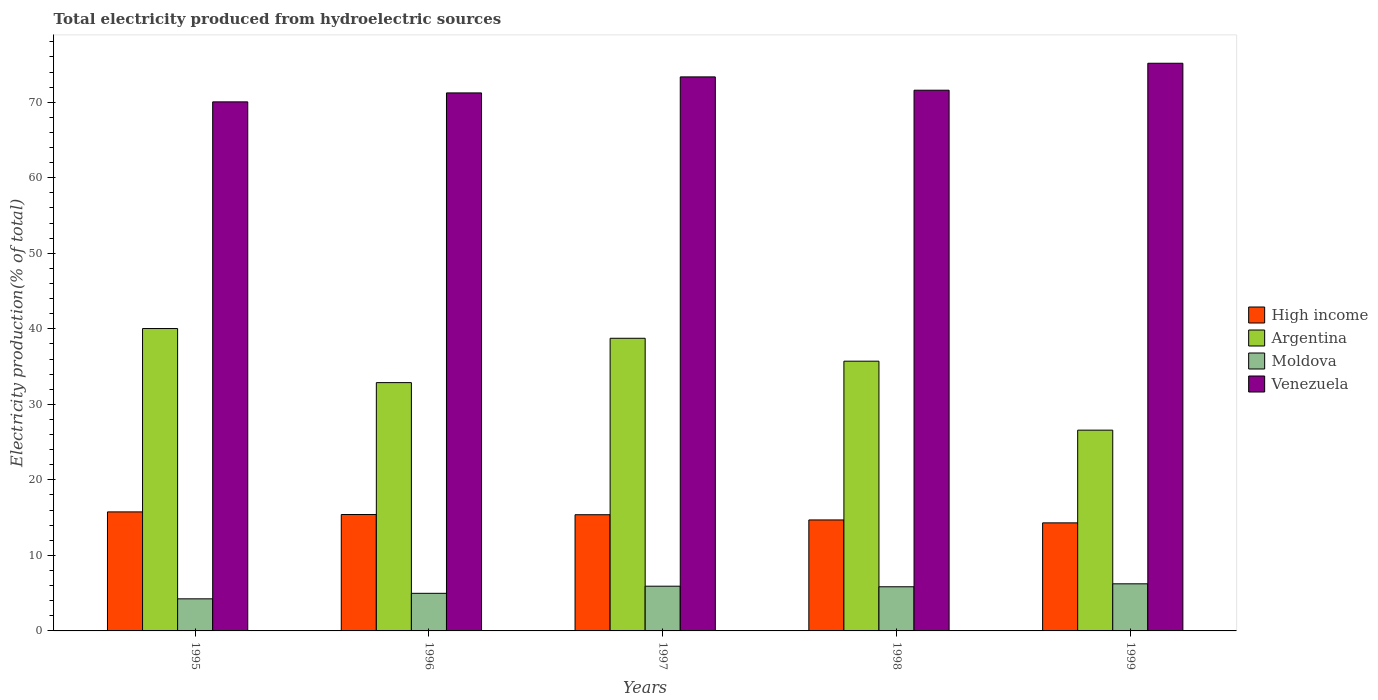Are the number of bars on each tick of the X-axis equal?
Ensure brevity in your answer.  Yes. What is the label of the 1st group of bars from the left?
Provide a succinct answer. 1995. What is the total electricity produced in High income in 1997?
Your answer should be compact. 15.39. Across all years, what is the maximum total electricity produced in Moldova?
Make the answer very short. 6.24. Across all years, what is the minimum total electricity produced in Moldova?
Your answer should be compact. 4.25. In which year was the total electricity produced in Venezuela maximum?
Provide a succinct answer. 1999. In which year was the total electricity produced in Venezuela minimum?
Your answer should be very brief. 1995. What is the total total electricity produced in High income in the graph?
Make the answer very short. 75.56. What is the difference between the total electricity produced in High income in 1995 and that in 1997?
Your answer should be very brief. 0.37. What is the difference between the total electricity produced in Argentina in 1996 and the total electricity produced in Venezuela in 1995?
Give a very brief answer. -37.17. What is the average total electricity produced in Argentina per year?
Provide a succinct answer. 34.79. In the year 1998, what is the difference between the total electricity produced in Moldova and total electricity produced in Venezuela?
Your answer should be very brief. -65.75. In how many years, is the total electricity produced in Venezuela greater than 10 %?
Offer a very short reply. 5. What is the ratio of the total electricity produced in Moldova in 1995 to that in 1997?
Keep it short and to the point. 0.72. Is the difference between the total electricity produced in Moldova in 1995 and 1998 greater than the difference between the total electricity produced in Venezuela in 1995 and 1998?
Ensure brevity in your answer.  No. What is the difference between the highest and the second highest total electricity produced in Venezuela?
Offer a terse response. 1.81. What is the difference between the highest and the lowest total electricity produced in Venezuela?
Give a very brief answer. 5.11. Is the sum of the total electricity produced in High income in 1997 and 1999 greater than the maximum total electricity produced in Moldova across all years?
Offer a terse response. Yes. What does the 1st bar from the right in 1995 represents?
Offer a terse response. Venezuela. How many bars are there?
Your response must be concise. 20. Does the graph contain grids?
Offer a very short reply. No. How many legend labels are there?
Your response must be concise. 4. How are the legend labels stacked?
Provide a succinct answer. Vertical. What is the title of the graph?
Ensure brevity in your answer.  Total electricity produced from hydroelectric sources. Does "Fragile and conflict affected situations" appear as one of the legend labels in the graph?
Your response must be concise. No. What is the label or title of the X-axis?
Offer a very short reply. Years. What is the label or title of the Y-axis?
Your answer should be very brief. Electricity production(% of total). What is the Electricity production(% of total) in High income in 1995?
Offer a terse response. 15.76. What is the Electricity production(% of total) in Argentina in 1995?
Ensure brevity in your answer.  40.04. What is the Electricity production(% of total) in Moldova in 1995?
Provide a short and direct response. 4.25. What is the Electricity production(% of total) in Venezuela in 1995?
Your answer should be compact. 70.05. What is the Electricity production(% of total) in High income in 1996?
Your response must be concise. 15.41. What is the Electricity production(% of total) in Argentina in 1996?
Keep it short and to the point. 32.88. What is the Electricity production(% of total) in Moldova in 1996?
Offer a very short reply. 4.98. What is the Electricity production(% of total) in Venezuela in 1996?
Provide a short and direct response. 71.24. What is the Electricity production(% of total) in High income in 1997?
Make the answer very short. 15.39. What is the Electricity production(% of total) of Argentina in 1997?
Your answer should be compact. 38.75. What is the Electricity production(% of total) of Moldova in 1997?
Offer a very short reply. 5.92. What is the Electricity production(% of total) in Venezuela in 1997?
Your answer should be compact. 73.36. What is the Electricity production(% of total) in High income in 1998?
Your response must be concise. 14.69. What is the Electricity production(% of total) in Argentina in 1998?
Provide a short and direct response. 35.72. What is the Electricity production(% of total) in Moldova in 1998?
Provide a succinct answer. 5.84. What is the Electricity production(% of total) of Venezuela in 1998?
Offer a very short reply. 71.6. What is the Electricity production(% of total) of High income in 1999?
Provide a short and direct response. 14.31. What is the Electricity production(% of total) of Argentina in 1999?
Provide a succinct answer. 26.58. What is the Electricity production(% of total) in Moldova in 1999?
Your answer should be compact. 6.24. What is the Electricity production(% of total) of Venezuela in 1999?
Your response must be concise. 75.16. Across all years, what is the maximum Electricity production(% of total) of High income?
Keep it short and to the point. 15.76. Across all years, what is the maximum Electricity production(% of total) of Argentina?
Make the answer very short. 40.04. Across all years, what is the maximum Electricity production(% of total) of Moldova?
Give a very brief answer. 6.24. Across all years, what is the maximum Electricity production(% of total) of Venezuela?
Provide a succinct answer. 75.16. Across all years, what is the minimum Electricity production(% of total) of High income?
Ensure brevity in your answer.  14.31. Across all years, what is the minimum Electricity production(% of total) in Argentina?
Make the answer very short. 26.58. Across all years, what is the minimum Electricity production(% of total) of Moldova?
Ensure brevity in your answer.  4.25. Across all years, what is the minimum Electricity production(% of total) in Venezuela?
Offer a terse response. 70.05. What is the total Electricity production(% of total) in High income in the graph?
Your response must be concise. 75.56. What is the total Electricity production(% of total) of Argentina in the graph?
Your response must be concise. 173.97. What is the total Electricity production(% of total) of Moldova in the graph?
Provide a succinct answer. 27.23. What is the total Electricity production(% of total) in Venezuela in the graph?
Provide a succinct answer. 361.41. What is the difference between the Electricity production(% of total) in High income in 1995 and that in 1996?
Your response must be concise. 0.35. What is the difference between the Electricity production(% of total) in Argentina in 1995 and that in 1996?
Give a very brief answer. 7.16. What is the difference between the Electricity production(% of total) of Moldova in 1995 and that in 1996?
Your answer should be very brief. -0.73. What is the difference between the Electricity production(% of total) of Venezuela in 1995 and that in 1996?
Keep it short and to the point. -1.19. What is the difference between the Electricity production(% of total) of High income in 1995 and that in 1997?
Ensure brevity in your answer.  0.37. What is the difference between the Electricity production(% of total) of Argentina in 1995 and that in 1997?
Your answer should be compact. 1.29. What is the difference between the Electricity production(% of total) in Moldova in 1995 and that in 1997?
Your response must be concise. -1.67. What is the difference between the Electricity production(% of total) of Venezuela in 1995 and that in 1997?
Your response must be concise. -3.31. What is the difference between the Electricity production(% of total) of High income in 1995 and that in 1998?
Your response must be concise. 1.07. What is the difference between the Electricity production(% of total) in Argentina in 1995 and that in 1998?
Give a very brief answer. 4.32. What is the difference between the Electricity production(% of total) in Moldova in 1995 and that in 1998?
Your answer should be very brief. -1.6. What is the difference between the Electricity production(% of total) of Venezuela in 1995 and that in 1998?
Your answer should be compact. -1.54. What is the difference between the Electricity production(% of total) of High income in 1995 and that in 1999?
Give a very brief answer. 1.45. What is the difference between the Electricity production(% of total) in Argentina in 1995 and that in 1999?
Give a very brief answer. 13.45. What is the difference between the Electricity production(% of total) in Moldova in 1995 and that in 1999?
Offer a very short reply. -1.99. What is the difference between the Electricity production(% of total) of Venezuela in 1995 and that in 1999?
Your answer should be very brief. -5.11. What is the difference between the Electricity production(% of total) of High income in 1996 and that in 1997?
Your response must be concise. 0.03. What is the difference between the Electricity production(% of total) of Argentina in 1996 and that in 1997?
Make the answer very short. -5.87. What is the difference between the Electricity production(% of total) of Moldova in 1996 and that in 1997?
Your response must be concise. -0.94. What is the difference between the Electricity production(% of total) of Venezuela in 1996 and that in 1997?
Offer a very short reply. -2.12. What is the difference between the Electricity production(% of total) of High income in 1996 and that in 1998?
Provide a short and direct response. 0.72. What is the difference between the Electricity production(% of total) of Argentina in 1996 and that in 1998?
Your answer should be compact. -2.84. What is the difference between the Electricity production(% of total) of Moldova in 1996 and that in 1998?
Provide a short and direct response. -0.87. What is the difference between the Electricity production(% of total) of Venezuela in 1996 and that in 1998?
Ensure brevity in your answer.  -0.36. What is the difference between the Electricity production(% of total) of High income in 1996 and that in 1999?
Your response must be concise. 1.1. What is the difference between the Electricity production(% of total) of Argentina in 1996 and that in 1999?
Provide a short and direct response. 6.29. What is the difference between the Electricity production(% of total) in Moldova in 1996 and that in 1999?
Make the answer very short. -1.26. What is the difference between the Electricity production(% of total) of Venezuela in 1996 and that in 1999?
Your answer should be compact. -3.93. What is the difference between the Electricity production(% of total) of High income in 1997 and that in 1998?
Keep it short and to the point. 0.69. What is the difference between the Electricity production(% of total) in Argentina in 1997 and that in 1998?
Your answer should be very brief. 3.03. What is the difference between the Electricity production(% of total) in Moldova in 1997 and that in 1998?
Provide a succinct answer. 0.08. What is the difference between the Electricity production(% of total) of Venezuela in 1997 and that in 1998?
Your answer should be very brief. 1.76. What is the difference between the Electricity production(% of total) in High income in 1997 and that in 1999?
Your response must be concise. 1.08. What is the difference between the Electricity production(% of total) of Argentina in 1997 and that in 1999?
Give a very brief answer. 12.16. What is the difference between the Electricity production(% of total) in Moldova in 1997 and that in 1999?
Ensure brevity in your answer.  -0.32. What is the difference between the Electricity production(% of total) in Venezuela in 1997 and that in 1999?
Your response must be concise. -1.81. What is the difference between the Electricity production(% of total) in High income in 1998 and that in 1999?
Give a very brief answer. 0.39. What is the difference between the Electricity production(% of total) in Argentina in 1998 and that in 1999?
Ensure brevity in your answer.  9.13. What is the difference between the Electricity production(% of total) of Moldova in 1998 and that in 1999?
Offer a terse response. -0.39. What is the difference between the Electricity production(% of total) of Venezuela in 1998 and that in 1999?
Provide a succinct answer. -3.57. What is the difference between the Electricity production(% of total) of High income in 1995 and the Electricity production(% of total) of Argentina in 1996?
Your answer should be compact. -17.12. What is the difference between the Electricity production(% of total) of High income in 1995 and the Electricity production(% of total) of Moldova in 1996?
Give a very brief answer. 10.78. What is the difference between the Electricity production(% of total) of High income in 1995 and the Electricity production(% of total) of Venezuela in 1996?
Make the answer very short. -55.48. What is the difference between the Electricity production(% of total) of Argentina in 1995 and the Electricity production(% of total) of Moldova in 1996?
Ensure brevity in your answer.  35.06. What is the difference between the Electricity production(% of total) in Argentina in 1995 and the Electricity production(% of total) in Venezuela in 1996?
Ensure brevity in your answer.  -31.2. What is the difference between the Electricity production(% of total) of Moldova in 1995 and the Electricity production(% of total) of Venezuela in 1996?
Make the answer very short. -66.99. What is the difference between the Electricity production(% of total) of High income in 1995 and the Electricity production(% of total) of Argentina in 1997?
Offer a very short reply. -22.99. What is the difference between the Electricity production(% of total) in High income in 1995 and the Electricity production(% of total) in Moldova in 1997?
Ensure brevity in your answer.  9.84. What is the difference between the Electricity production(% of total) in High income in 1995 and the Electricity production(% of total) in Venezuela in 1997?
Provide a short and direct response. -57.6. What is the difference between the Electricity production(% of total) of Argentina in 1995 and the Electricity production(% of total) of Moldova in 1997?
Give a very brief answer. 34.12. What is the difference between the Electricity production(% of total) of Argentina in 1995 and the Electricity production(% of total) of Venezuela in 1997?
Ensure brevity in your answer.  -33.32. What is the difference between the Electricity production(% of total) of Moldova in 1995 and the Electricity production(% of total) of Venezuela in 1997?
Keep it short and to the point. -69.11. What is the difference between the Electricity production(% of total) in High income in 1995 and the Electricity production(% of total) in Argentina in 1998?
Make the answer very short. -19.96. What is the difference between the Electricity production(% of total) in High income in 1995 and the Electricity production(% of total) in Moldova in 1998?
Offer a terse response. 9.92. What is the difference between the Electricity production(% of total) in High income in 1995 and the Electricity production(% of total) in Venezuela in 1998?
Provide a short and direct response. -55.84. What is the difference between the Electricity production(% of total) of Argentina in 1995 and the Electricity production(% of total) of Moldova in 1998?
Your response must be concise. 34.19. What is the difference between the Electricity production(% of total) of Argentina in 1995 and the Electricity production(% of total) of Venezuela in 1998?
Keep it short and to the point. -31.56. What is the difference between the Electricity production(% of total) of Moldova in 1995 and the Electricity production(% of total) of Venezuela in 1998?
Give a very brief answer. -67.35. What is the difference between the Electricity production(% of total) of High income in 1995 and the Electricity production(% of total) of Argentina in 1999?
Offer a very short reply. -10.82. What is the difference between the Electricity production(% of total) in High income in 1995 and the Electricity production(% of total) in Moldova in 1999?
Your answer should be compact. 9.52. What is the difference between the Electricity production(% of total) of High income in 1995 and the Electricity production(% of total) of Venezuela in 1999?
Your answer should be very brief. -59.4. What is the difference between the Electricity production(% of total) in Argentina in 1995 and the Electricity production(% of total) in Moldova in 1999?
Keep it short and to the point. 33.8. What is the difference between the Electricity production(% of total) of Argentina in 1995 and the Electricity production(% of total) of Venezuela in 1999?
Provide a succinct answer. -35.13. What is the difference between the Electricity production(% of total) in Moldova in 1995 and the Electricity production(% of total) in Venezuela in 1999?
Give a very brief answer. -70.92. What is the difference between the Electricity production(% of total) in High income in 1996 and the Electricity production(% of total) in Argentina in 1997?
Provide a succinct answer. -23.34. What is the difference between the Electricity production(% of total) in High income in 1996 and the Electricity production(% of total) in Moldova in 1997?
Provide a short and direct response. 9.49. What is the difference between the Electricity production(% of total) of High income in 1996 and the Electricity production(% of total) of Venezuela in 1997?
Provide a short and direct response. -57.95. What is the difference between the Electricity production(% of total) in Argentina in 1996 and the Electricity production(% of total) in Moldova in 1997?
Make the answer very short. 26.96. What is the difference between the Electricity production(% of total) in Argentina in 1996 and the Electricity production(% of total) in Venezuela in 1997?
Offer a very short reply. -40.48. What is the difference between the Electricity production(% of total) in Moldova in 1996 and the Electricity production(% of total) in Venezuela in 1997?
Offer a terse response. -68.38. What is the difference between the Electricity production(% of total) in High income in 1996 and the Electricity production(% of total) in Argentina in 1998?
Ensure brevity in your answer.  -20.3. What is the difference between the Electricity production(% of total) of High income in 1996 and the Electricity production(% of total) of Moldova in 1998?
Make the answer very short. 9.57. What is the difference between the Electricity production(% of total) in High income in 1996 and the Electricity production(% of total) in Venezuela in 1998?
Ensure brevity in your answer.  -56.18. What is the difference between the Electricity production(% of total) in Argentina in 1996 and the Electricity production(% of total) in Moldova in 1998?
Keep it short and to the point. 27.03. What is the difference between the Electricity production(% of total) in Argentina in 1996 and the Electricity production(% of total) in Venezuela in 1998?
Give a very brief answer. -38.72. What is the difference between the Electricity production(% of total) of Moldova in 1996 and the Electricity production(% of total) of Venezuela in 1998?
Provide a short and direct response. -66.62. What is the difference between the Electricity production(% of total) in High income in 1996 and the Electricity production(% of total) in Argentina in 1999?
Ensure brevity in your answer.  -11.17. What is the difference between the Electricity production(% of total) of High income in 1996 and the Electricity production(% of total) of Moldova in 1999?
Provide a succinct answer. 9.18. What is the difference between the Electricity production(% of total) of High income in 1996 and the Electricity production(% of total) of Venezuela in 1999?
Offer a terse response. -59.75. What is the difference between the Electricity production(% of total) in Argentina in 1996 and the Electricity production(% of total) in Moldova in 1999?
Your answer should be very brief. 26.64. What is the difference between the Electricity production(% of total) of Argentina in 1996 and the Electricity production(% of total) of Venezuela in 1999?
Offer a terse response. -42.29. What is the difference between the Electricity production(% of total) of Moldova in 1996 and the Electricity production(% of total) of Venezuela in 1999?
Provide a succinct answer. -70.19. What is the difference between the Electricity production(% of total) of High income in 1997 and the Electricity production(% of total) of Argentina in 1998?
Provide a short and direct response. -20.33. What is the difference between the Electricity production(% of total) in High income in 1997 and the Electricity production(% of total) in Moldova in 1998?
Keep it short and to the point. 9.54. What is the difference between the Electricity production(% of total) of High income in 1997 and the Electricity production(% of total) of Venezuela in 1998?
Your answer should be compact. -56.21. What is the difference between the Electricity production(% of total) of Argentina in 1997 and the Electricity production(% of total) of Moldova in 1998?
Provide a short and direct response. 32.9. What is the difference between the Electricity production(% of total) of Argentina in 1997 and the Electricity production(% of total) of Venezuela in 1998?
Make the answer very short. -32.85. What is the difference between the Electricity production(% of total) of Moldova in 1997 and the Electricity production(% of total) of Venezuela in 1998?
Offer a very short reply. -65.67. What is the difference between the Electricity production(% of total) in High income in 1997 and the Electricity production(% of total) in Argentina in 1999?
Offer a terse response. -11.2. What is the difference between the Electricity production(% of total) of High income in 1997 and the Electricity production(% of total) of Moldova in 1999?
Your answer should be compact. 9.15. What is the difference between the Electricity production(% of total) in High income in 1997 and the Electricity production(% of total) in Venezuela in 1999?
Provide a short and direct response. -59.78. What is the difference between the Electricity production(% of total) in Argentina in 1997 and the Electricity production(% of total) in Moldova in 1999?
Offer a terse response. 32.51. What is the difference between the Electricity production(% of total) in Argentina in 1997 and the Electricity production(% of total) in Venezuela in 1999?
Offer a terse response. -36.42. What is the difference between the Electricity production(% of total) of Moldova in 1997 and the Electricity production(% of total) of Venezuela in 1999?
Give a very brief answer. -69.24. What is the difference between the Electricity production(% of total) in High income in 1998 and the Electricity production(% of total) in Argentina in 1999?
Your answer should be compact. -11.89. What is the difference between the Electricity production(% of total) in High income in 1998 and the Electricity production(% of total) in Moldova in 1999?
Make the answer very short. 8.46. What is the difference between the Electricity production(% of total) of High income in 1998 and the Electricity production(% of total) of Venezuela in 1999?
Ensure brevity in your answer.  -60.47. What is the difference between the Electricity production(% of total) of Argentina in 1998 and the Electricity production(% of total) of Moldova in 1999?
Ensure brevity in your answer.  29.48. What is the difference between the Electricity production(% of total) in Argentina in 1998 and the Electricity production(% of total) in Venezuela in 1999?
Ensure brevity in your answer.  -39.45. What is the difference between the Electricity production(% of total) of Moldova in 1998 and the Electricity production(% of total) of Venezuela in 1999?
Give a very brief answer. -69.32. What is the average Electricity production(% of total) in High income per year?
Make the answer very short. 15.11. What is the average Electricity production(% of total) of Argentina per year?
Keep it short and to the point. 34.79. What is the average Electricity production(% of total) of Moldova per year?
Provide a succinct answer. 5.45. What is the average Electricity production(% of total) in Venezuela per year?
Keep it short and to the point. 72.28. In the year 1995, what is the difference between the Electricity production(% of total) of High income and Electricity production(% of total) of Argentina?
Give a very brief answer. -24.28. In the year 1995, what is the difference between the Electricity production(% of total) in High income and Electricity production(% of total) in Moldova?
Your answer should be very brief. 11.51. In the year 1995, what is the difference between the Electricity production(% of total) of High income and Electricity production(% of total) of Venezuela?
Make the answer very short. -54.29. In the year 1995, what is the difference between the Electricity production(% of total) of Argentina and Electricity production(% of total) of Moldova?
Offer a terse response. 35.79. In the year 1995, what is the difference between the Electricity production(% of total) of Argentina and Electricity production(% of total) of Venezuela?
Your answer should be compact. -30.01. In the year 1995, what is the difference between the Electricity production(% of total) of Moldova and Electricity production(% of total) of Venezuela?
Give a very brief answer. -65.8. In the year 1996, what is the difference between the Electricity production(% of total) of High income and Electricity production(% of total) of Argentina?
Ensure brevity in your answer.  -17.47. In the year 1996, what is the difference between the Electricity production(% of total) of High income and Electricity production(% of total) of Moldova?
Offer a very short reply. 10.43. In the year 1996, what is the difference between the Electricity production(% of total) in High income and Electricity production(% of total) in Venezuela?
Make the answer very short. -55.82. In the year 1996, what is the difference between the Electricity production(% of total) of Argentina and Electricity production(% of total) of Moldova?
Offer a terse response. 27.9. In the year 1996, what is the difference between the Electricity production(% of total) in Argentina and Electricity production(% of total) in Venezuela?
Make the answer very short. -38.36. In the year 1996, what is the difference between the Electricity production(% of total) in Moldova and Electricity production(% of total) in Venezuela?
Keep it short and to the point. -66.26. In the year 1997, what is the difference between the Electricity production(% of total) of High income and Electricity production(% of total) of Argentina?
Provide a succinct answer. -23.36. In the year 1997, what is the difference between the Electricity production(% of total) in High income and Electricity production(% of total) in Moldova?
Make the answer very short. 9.46. In the year 1997, what is the difference between the Electricity production(% of total) of High income and Electricity production(% of total) of Venezuela?
Offer a terse response. -57.97. In the year 1997, what is the difference between the Electricity production(% of total) of Argentina and Electricity production(% of total) of Moldova?
Offer a very short reply. 32.83. In the year 1997, what is the difference between the Electricity production(% of total) in Argentina and Electricity production(% of total) in Venezuela?
Your answer should be compact. -34.61. In the year 1997, what is the difference between the Electricity production(% of total) in Moldova and Electricity production(% of total) in Venezuela?
Provide a succinct answer. -67.44. In the year 1998, what is the difference between the Electricity production(% of total) in High income and Electricity production(% of total) in Argentina?
Your response must be concise. -21.02. In the year 1998, what is the difference between the Electricity production(% of total) of High income and Electricity production(% of total) of Moldova?
Provide a short and direct response. 8.85. In the year 1998, what is the difference between the Electricity production(% of total) in High income and Electricity production(% of total) in Venezuela?
Offer a terse response. -56.9. In the year 1998, what is the difference between the Electricity production(% of total) of Argentina and Electricity production(% of total) of Moldova?
Make the answer very short. 29.87. In the year 1998, what is the difference between the Electricity production(% of total) in Argentina and Electricity production(% of total) in Venezuela?
Offer a very short reply. -35.88. In the year 1998, what is the difference between the Electricity production(% of total) of Moldova and Electricity production(% of total) of Venezuela?
Your answer should be very brief. -65.75. In the year 1999, what is the difference between the Electricity production(% of total) in High income and Electricity production(% of total) in Argentina?
Give a very brief answer. -12.28. In the year 1999, what is the difference between the Electricity production(% of total) in High income and Electricity production(% of total) in Moldova?
Provide a succinct answer. 8.07. In the year 1999, what is the difference between the Electricity production(% of total) of High income and Electricity production(% of total) of Venezuela?
Offer a very short reply. -60.86. In the year 1999, what is the difference between the Electricity production(% of total) in Argentina and Electricity production(% of total) in Moldova?
Give a very brief answer. 20.35. In the year 1999, what is the difference between the Electricity production(% of total) in Argentina and Electricity production(% of total) in Venezuela?
Your response must be concise. -48.58. In the year 1999, what is the difference between the Electricity production(% of total) in Moldova and Electricity production(% of total) in Venezuela?
Ensure brevity in your answer.  -68.93. What is the ratio of the Electricity production(% of total) of High income in 1995 to that in 1996?
Your response must be concise. 1.02. What is the ratio of the Electricity production(% of total) in Argentina in 1995 to that in 1996?
Make the answer very short. 1.22. What is the ratio of the Electricity production(% of total) in Moldova in 1995 to that in 1996?
Ensure brevity in your answer.  0.85. What is the ratio of the Electricity production(% of total) in Venezuela in 1995 to that in 1996?
Give a very brief answer. 0.98. What is the ratio of the Electricity production(% of total) in High income in 1995 to that in 1997?
Provide a succinct answer. 1.02. What is the ratio of the Electricity production(% of total) of Moldova in 1995 to that in 1997?
Make the answer very short. 0.72. What is the ratio of the Electricity production(% of total) in Venezuela in 1995 to that in 1997?
Keep it short and to the point. 0.95. What is the ratio of the Electricity production(% of total) in High income in 1995 to that in 1998?
Give a very brief answer. 1.07. What is the ratio of the Electricity production(% of total) in Argentina in 1995 to that in 1998?
Provide a succinct answer. 1.12. What is the ratio of the Electricity production(% of total) in Moldova in 1995 to that in 1998?
Give a very brief answer. 0.73. What is the ratio of the Electricity production(% of total) of Venezuela in 1995 to that in 1998?
Keep it short and to the point. 0.98. What is the ratio of the Electricity production(% of total) of High income in 1995 to that in 1999?
Make the answer very short. 1.1. What is the ratio of the Electricity production(% of total) in Argentina in 1995 to that in 1999?
Offer a very short reply. 1.51. What is the ratio of the Electricity production(% of total) in Moldova in 1995 to that in 1999?
Ensure brevity in your answer.  0.68. What is the ratio of the Electricity production(% of total) in Venezuela in 1995 to that in 1999?
Keep it short and to the point. 0.93. What is the ratio of the Electricity production(% of total) of Argentina in 1996 to that in 1997?
Your response must be concise. 0.85. What is the ratio of the Electricity production(% of total) of Moldova in 1996 to that in 1997?
Your answer should be very brief. 0.84. What is the ratio of the Electricity production(% of total) in Venezuela in 1996 to that in 1997?
Keep it short and to the point. 0.97. What is the ratio of the Electricity production(% of total) in High income in 1996 to that in 1998?
Offer a terse response. 1.05. What is the ratio of the Electricity production(% of total) of Argentina in 1996 to that in 1998?
Provide a short and direct response. 0.92. What is the ratio of the Electricity production(% of total) of Moldova in 1996 to that in 1998?
Provide a succinct answer. 0.85. What is the ratio of the Electricity production(% of total) of Venezuela in 1996 to that in 1998?
Provide a succinct answer. 0.99. What is the ratio of the Electricity production(% of total) of High income in 1996 to that in 1999?
Provide a short and direct response. 1.08. What is the ratio of the Electricity production(% of total) in Argentina in 1996 to that in 1999?
Offer a terse response. 1.24. What is the ratio of the Electricity production(% of total) in Moldova in 1996 to that in 1999?
Your response must be concise. 0.8. What is the ratio of the Electricity production(% of total) of Venezuela in 1996 to that in 1999?
Give a very brief answer. 0.95. What is the ratio of the Electricity production(% of total) of High income in 1997 to that in 1998?
Ensure brevity in your answer.  1.05. What is the ratio of the Electricity production(% of total) in Argentina in 1997 to that in 1998?
Provide a succinct answer. 1.08. What is the ratio of the Electricity production(% of total) of Moldova in 1997 to that in 1998?
Your answer should be compact. 1.01. What is the ratio of the Electricity production(% of total) in Venezuela in 1997 to that in 1998?
Keep it short and to the point. 1.02. What is the ratio of the Electricity production(% of total) in High income in 1997 to that in 1999?
Give a very brief answer. 1.08. What is the ratio of the Electricity production(% of total) in Argentina in 1997 to that in 1999?
Your answer should be very brief. 1.46. What is the ratio of the Electricity production(% of total) of Moldova in 1997 to that in 1999?
Provide a succinct answer. 0.95. What is the ratio of the Electricity production(% of total) in Venezuela in 1997 to that in 1999?
Give a very brief answer. 0.98. What is the ratio of the Electricity production(% of total) in High income in 1998 to that in 1999?
Your response must be concise. 1.03. What is the ratio of the Electricity production(% of total) of Argentina in 1998 to that in 1999?
Your answer should be compact. 1.34. What is the ratio of the Electricity production(% of total) in Moldova in 1998 to that in 1999?
Ensure brevity in your answer.  0.94. What is the ratio of the Electricity production(% of total) in Venezuela in 1998 to that in 1999?
Your answer should be compact. 0.95. What is the difference between the highest and the second highest Electricity production(% of total) of High income?
Make the answer very short. 0.35. What is the difference between the highest and the second highest Electricity production(% of total) of Argentina?
Provide a succinct answer. 1.29. What is the difference between the highest and the second highest Electricity production(% of total) in Moldova?
Provide a short and direct response. 0.32. What is the difference between the highest and the second highest Electricity production(% of total) of Venezuela?
Offer a terse response. 1.81. What is the difference between the highest and the lowest Electricity production(% of total) of High income?
Ensure brevity in your answer.  1.45. What is the difference between the highest and the lowest Electricity production(% of total) in Argentina?
Provide a succinct answer. 13.45. What is the difference between the highest and the lowest Electricity production(% of total) of Moldova?
Make the answer very short. 1.99. What is the difference between the highest and the lowest Electricity production(% of total) of Venezuela?
Give a very brief answer. 5.11. 